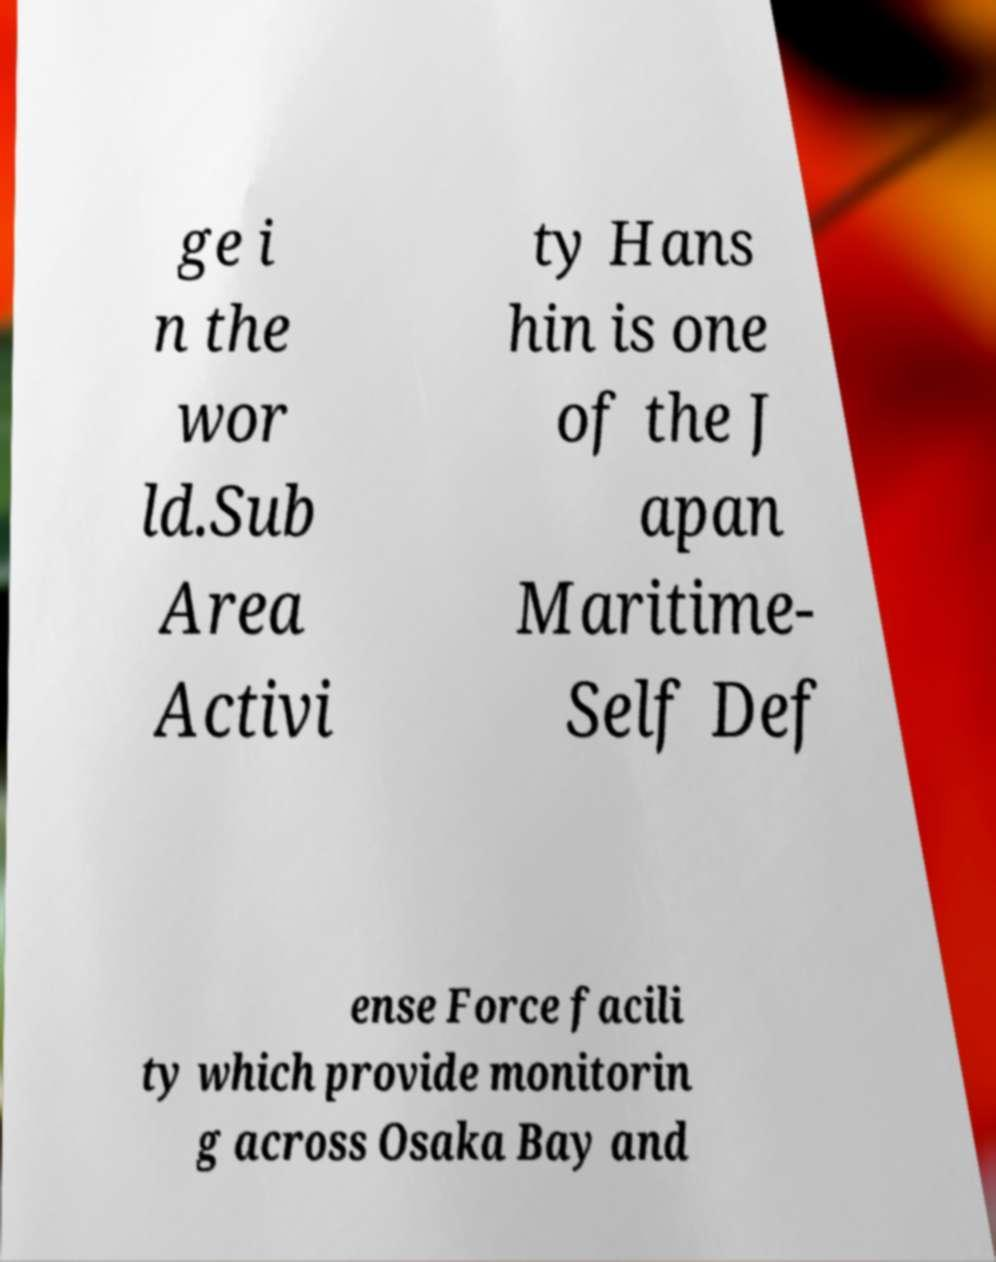Could you extract and type out the text from this image? ge i n the wor ld.Sub Area Activi ty Hans hin is one of the J apan Maritime- Self Def ense Force facili ty which provide monitorin g across Osaka Bay and 